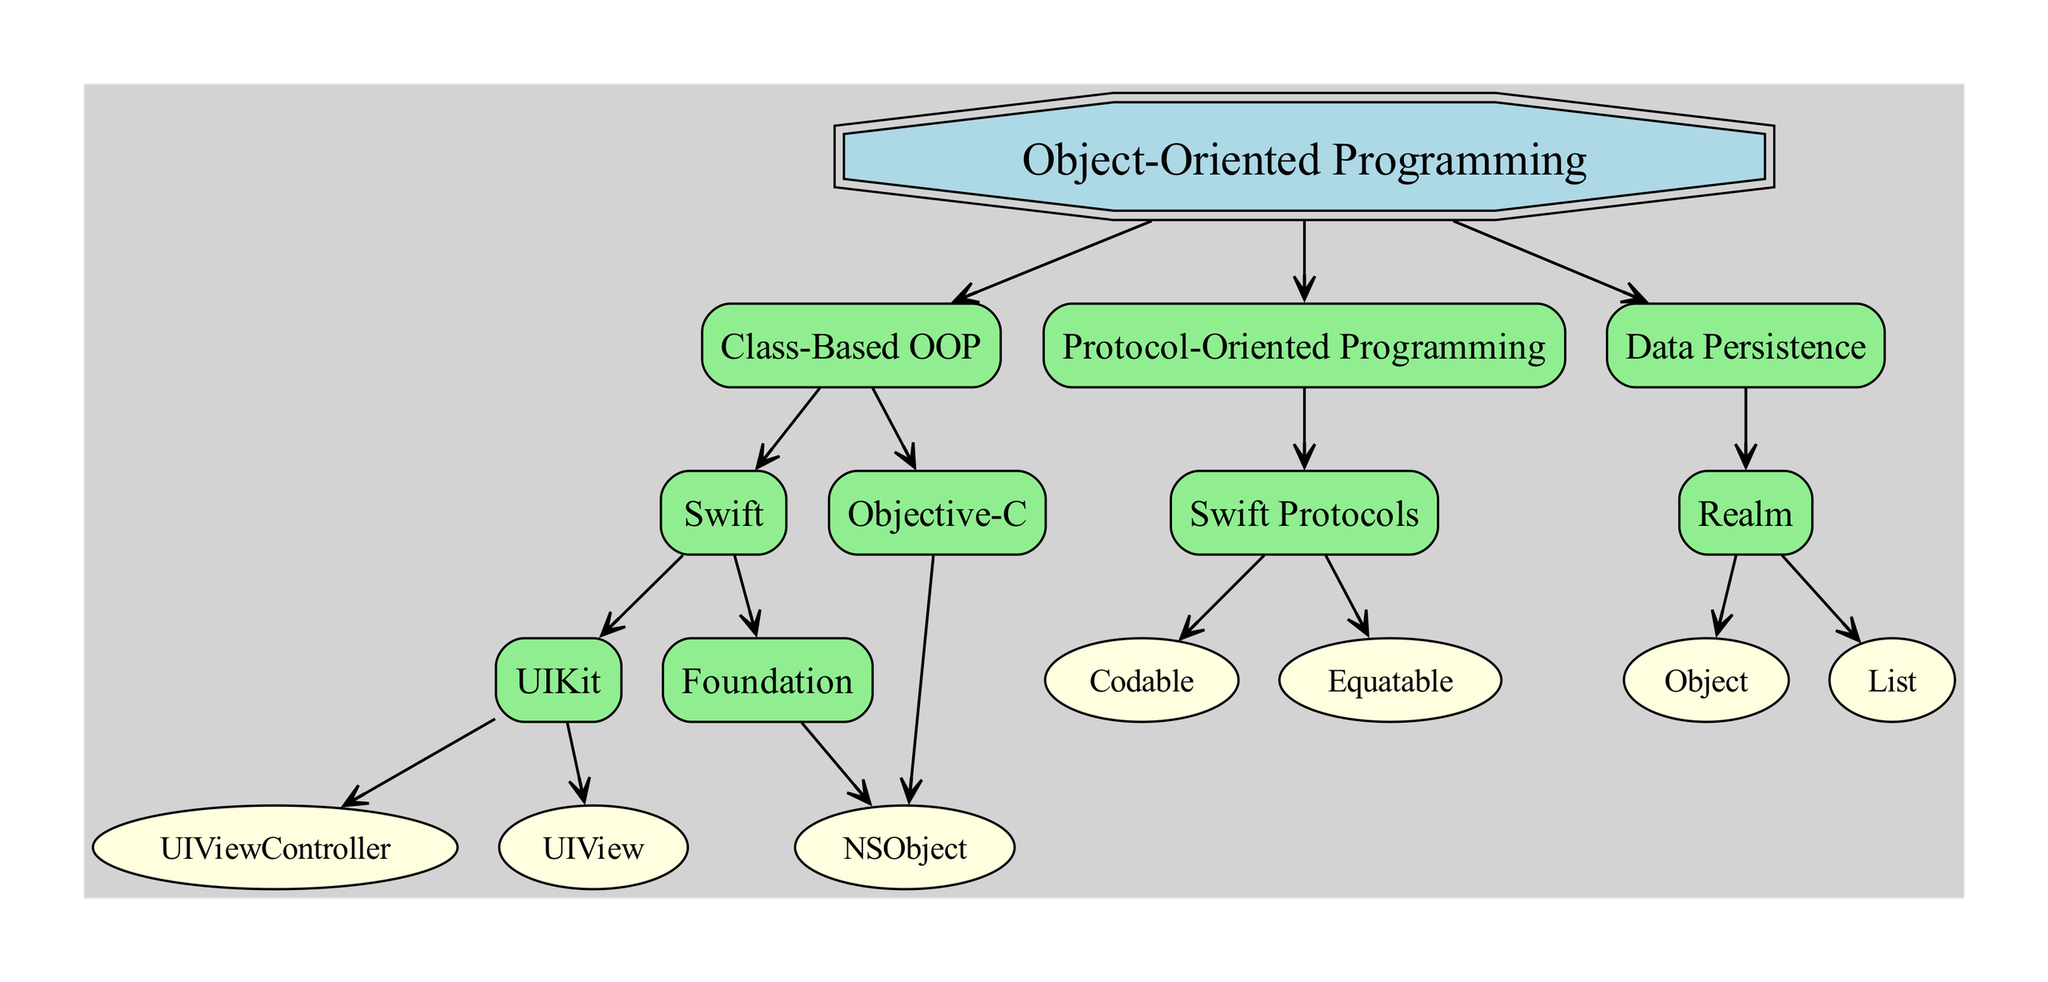What is the root of the family tree? The root node is the starting point of the diagram, which is explicitly labeled as "Object-Oriented Programming."
Answer: Object-Oriented Programming How many children does the "Class-Based OOP" node have? The "Class-Based OOP" node has two children: "Swift" and "Objective-C," making the total count two.
Answer: 2 What is a child of "Swift"? Looking at the "Swift" node, it has two children: "UIKit" and "Foundation." Therefore, one of these children is a valid answer and can be either one.
Answer: UIKit Which programming paradigm does "Realm" fall under? The "Realm" node is a child of the "Data Persistence" node, which is a child of the root "Object-Oriented Programming." Thus, it falls under the "Data Persistence" paradigm.
Answer: Data Persistence How many direct descendants does "Swift" have? The "Swift" node has two direct descendants: "UIKit" and "Foundation." Counting these gives a total of two descendants.
Answer: 2 What is the relationship between "UIView" and "UIViewController"? Both "UIView" and "UIViewController" are children of the "UIKit" node. This makes them siblings under the same parent.
Answer: Siblings Which node has only one direct child? The "Objective-C" node has only one direct child, which is "NSObject." This indicates a singular relationship in this context.
Answer: NSObject What type of programming is represented by "Swift Protocols"? "Swift Protocols" is the only child of "Protocol-Oriented Programming," thus it belongs to this specific programming type.
Answer: Protocol-Oriented Programming What are the two entities directly related to "Realm"? The direct children of the "Realm" node are "Object" and "List." Therefore, both of these are entities related to "Realm."
Answer: Object, List 